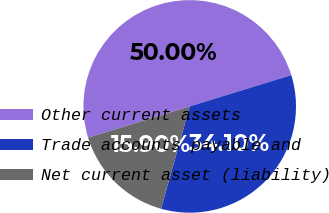<chart> <loc_0><loc_0><loc_500><loc_500><pie_chart><fcel>Other current assets<fcel>Trade accounts payable and<fcel>Net current asset (liability)<nl><fcel>50.0%<fcel>34.1%<fcel>15.9%<nl></chart> 